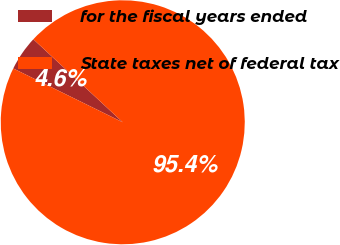Convert chart. <chart><loc_0><loc_0><loc_500><loc_500><pie_chart><fcel>for the fiscal years ended<fcel>State taxes net of federal tax<nl><fcel>4.64%<fcel>95.36%<nl></chart> 